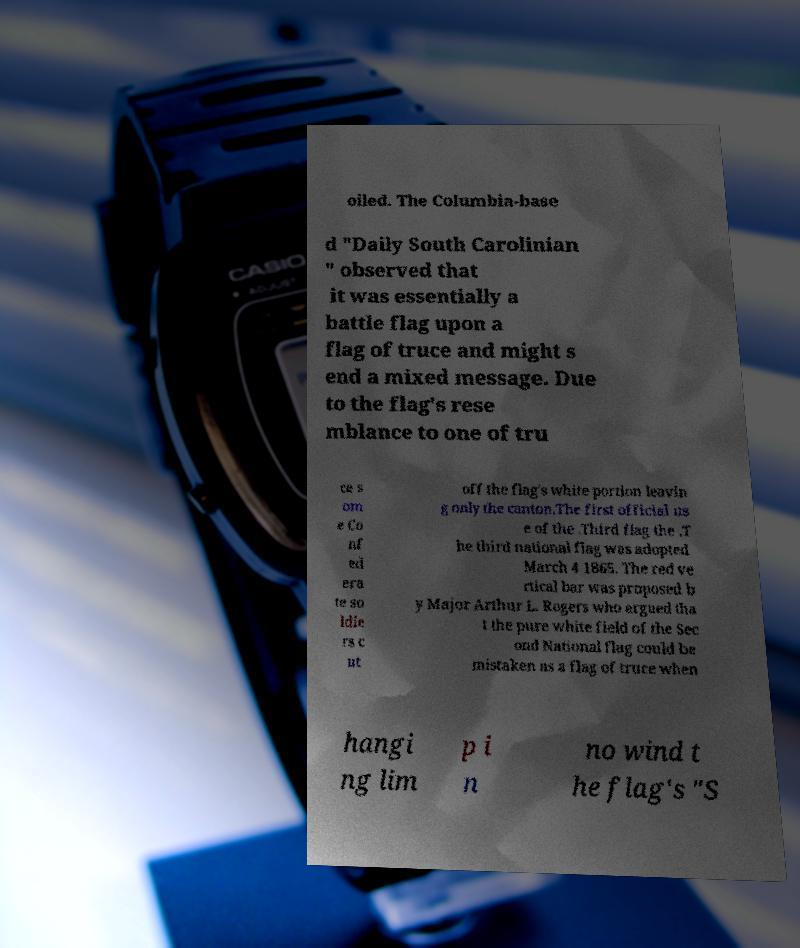Please read and relay the text visible in this image. What does it say? oiled. The Columbia-base d "Daily South Carolinian " observed that it was essentially a battle flag upon a flag of truce and might s end a mixed message. Due to the flag's rese mblance to one of tru ce s om e Co nf ed era te so ldie rs c ut off the flag's white portion leavin g only the canton.The first official us e of the .Third flag the .T he third national flag was adopted March 4 1865. The red ve rtical bar was proposed b y Major Arthur L. Rogers who argued tha t the pure white field of the Sec ond National flag could be mistaken as a flag of truce when hangi ng lim p i n no wind t he flag's "S 